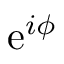<formula> <loc_0><loc_0><loc_500><loc_500>e ^ { i \phi }</formula> 